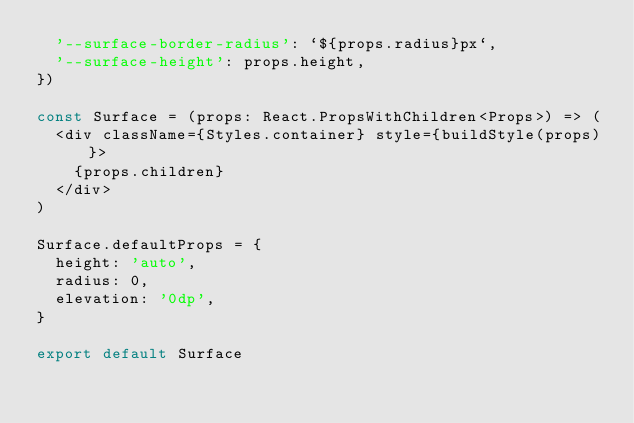Convert code to text. <code><loc_0><loc_0><loc_500><loc_500><_TypeScript_>  '--surface-border-radius': `${props.radius}px`,
  '--surface-height': props.height,
})

const Surface = (props: React.PropsWithChildren<Props>) => (
  <div className={Styles.container} style={buildStyle(props)}>
    {props.children}
  </div>
)

Surface.defaultProps = {
  height: 'auto',
  radius: 0,
  elevation: '0dp',
}

export default Surface</code> 